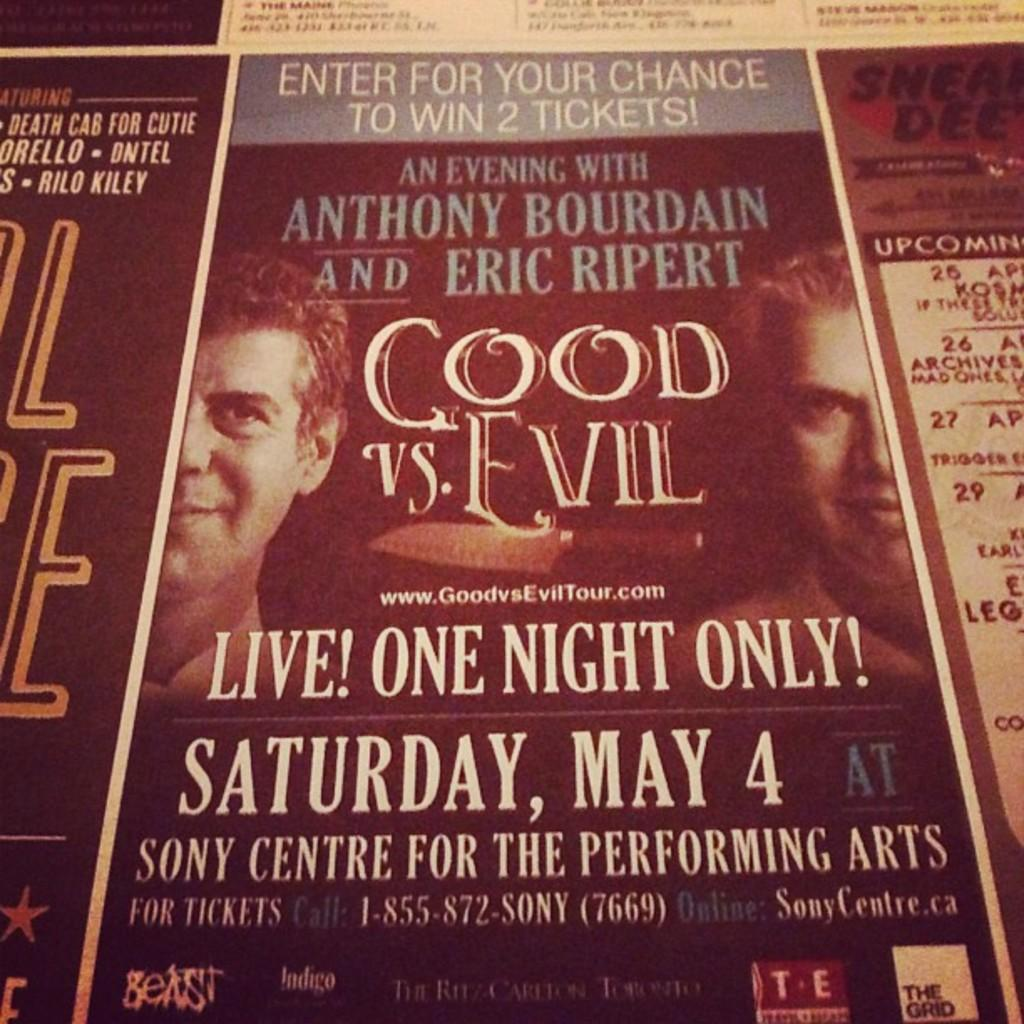Provide a one-sentence caption for the provided image. Live one night only poster with Anthony Bourdain and Eric Ripert. 